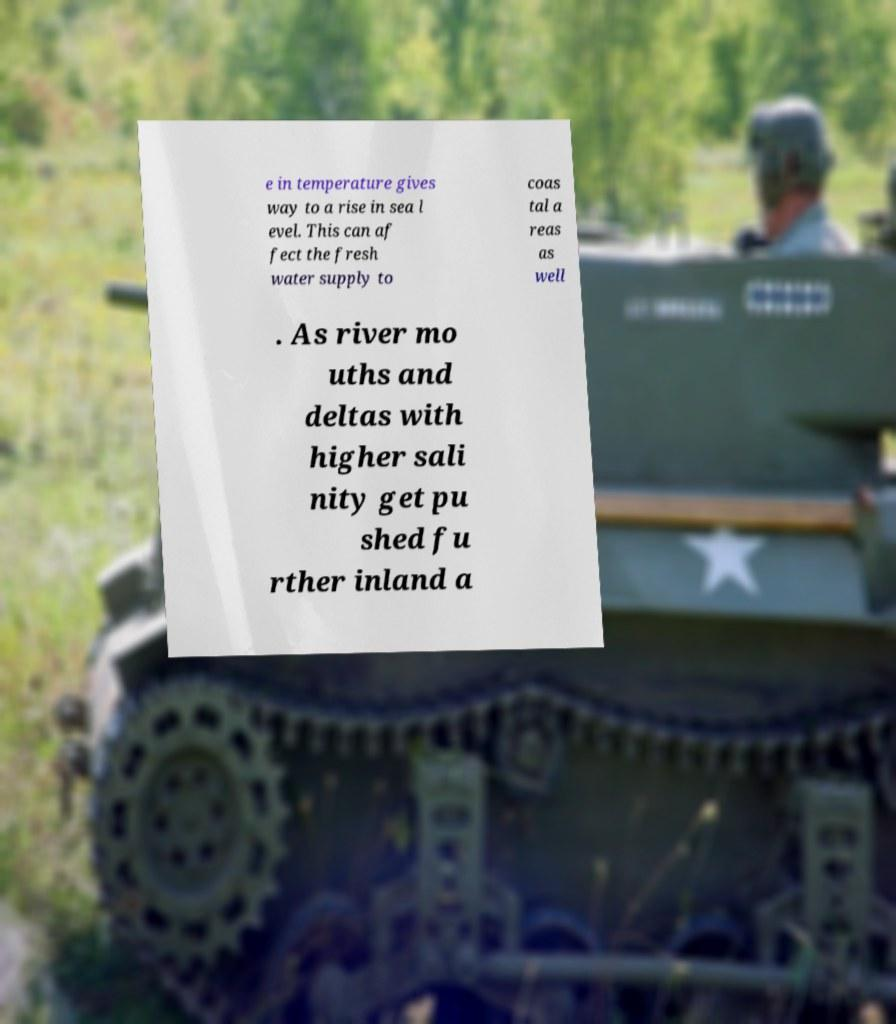Please identify and transcribe the text found in this image. e in temperature gives way to a rise in sea l evel. This can af fect the fresh water supply to coas tal a reas as well . As river mo uths and deltas with higher sali nity get pu shed fu rther inland a 